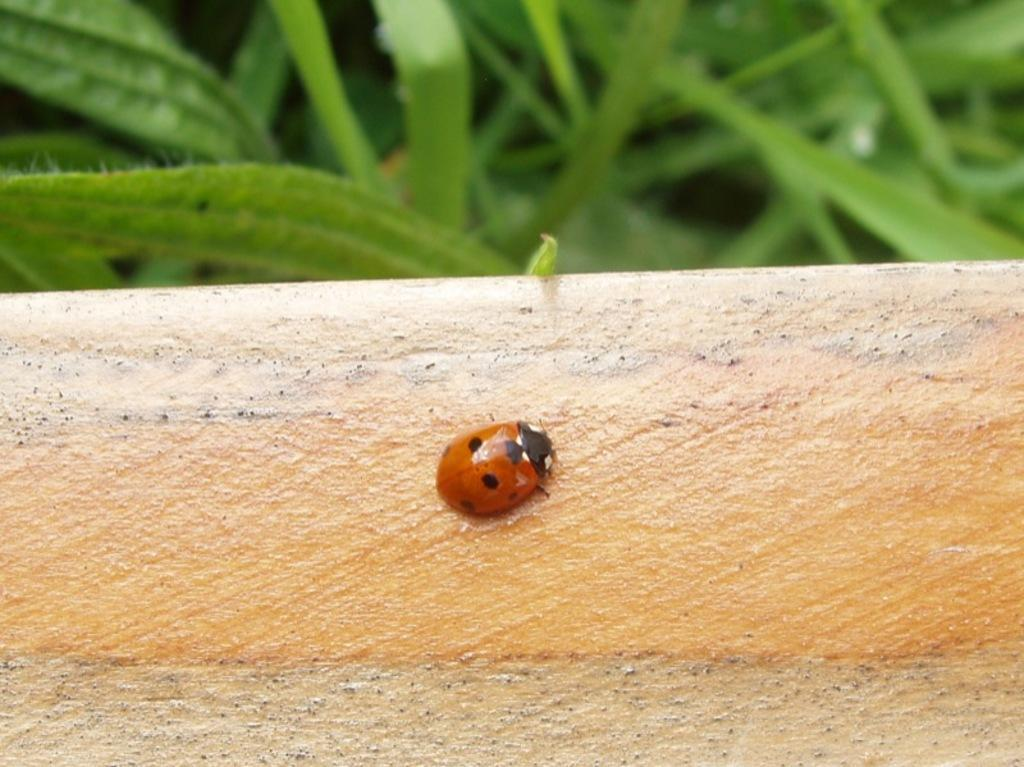What is present on the surface in the image? There is a bug on a surface in the image. What can be seen in the background of the image? There are leaves in the background of the image. What type of laborer is operating the machine in the image? There is no laborer or machine present in the image. 